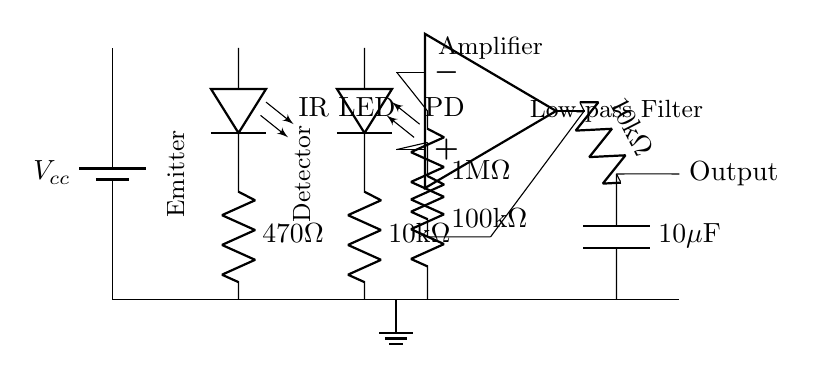What is the purpose of the LED in this circuit? The LED serves as an emitter, which generates light that illuminates the underlying tissue. Through light reflection, a photodiode detects the variations in light intensity due to blood flow, essential for measuring pulse rate.
Answer: Emitter What is the resistance value of the resistor in series with the LED? The resistor in series with the LED is labeled as 470 ohms, which limits the current flowing through the LED to prevent damage and ensures appropriate brightness.
Answer: 470 ohm What type of component is connected after the photodiode in the circuit? After the photodiode, a resistor labeled as 10k ohm is connected, which helps in converting the current generated by the photodiode into a voltage output for further processing by the amplifier.
Answer: Resistor What is the purpose of the operational amplifier in this circuit? The operational amplifier amplifies the small signal received from the photodiode's output, making it large enough to be processed by later components like the low-pass filter. Without amplification, the pulse signal would be too weak for accurate detection.
Answer: Amplification What is the value of the capacitor in the low-pass filter? The capacitor in the low-pass filter is labeled as 10 microfarads, which works together with the resistor to smooth out the signal, allowing only specific frequencies (like the pulse rate) to pass through while attenuating higher frequencies.
Answer: 10 microfarads What are the two main sections of this pulse rate monitor circuit? The circuit can be divided into the sensing section, which includes the LED and photodiode, capturing the pulse signal, and the processing section, which includes the operational amplifier and low-pass filter for signal conditioning and output.
Answer: Sensing and processing What component is used to filter out high-frequency noise? A low-pass filter is used to filter out high-frequency noise. It consists of a resistor and capacitor combination that allows low-frequency signals (like the heart rate) to pass while reducing unwanted high-frequency components for clear pulse monitoring.
Answer: Low-pass filter 